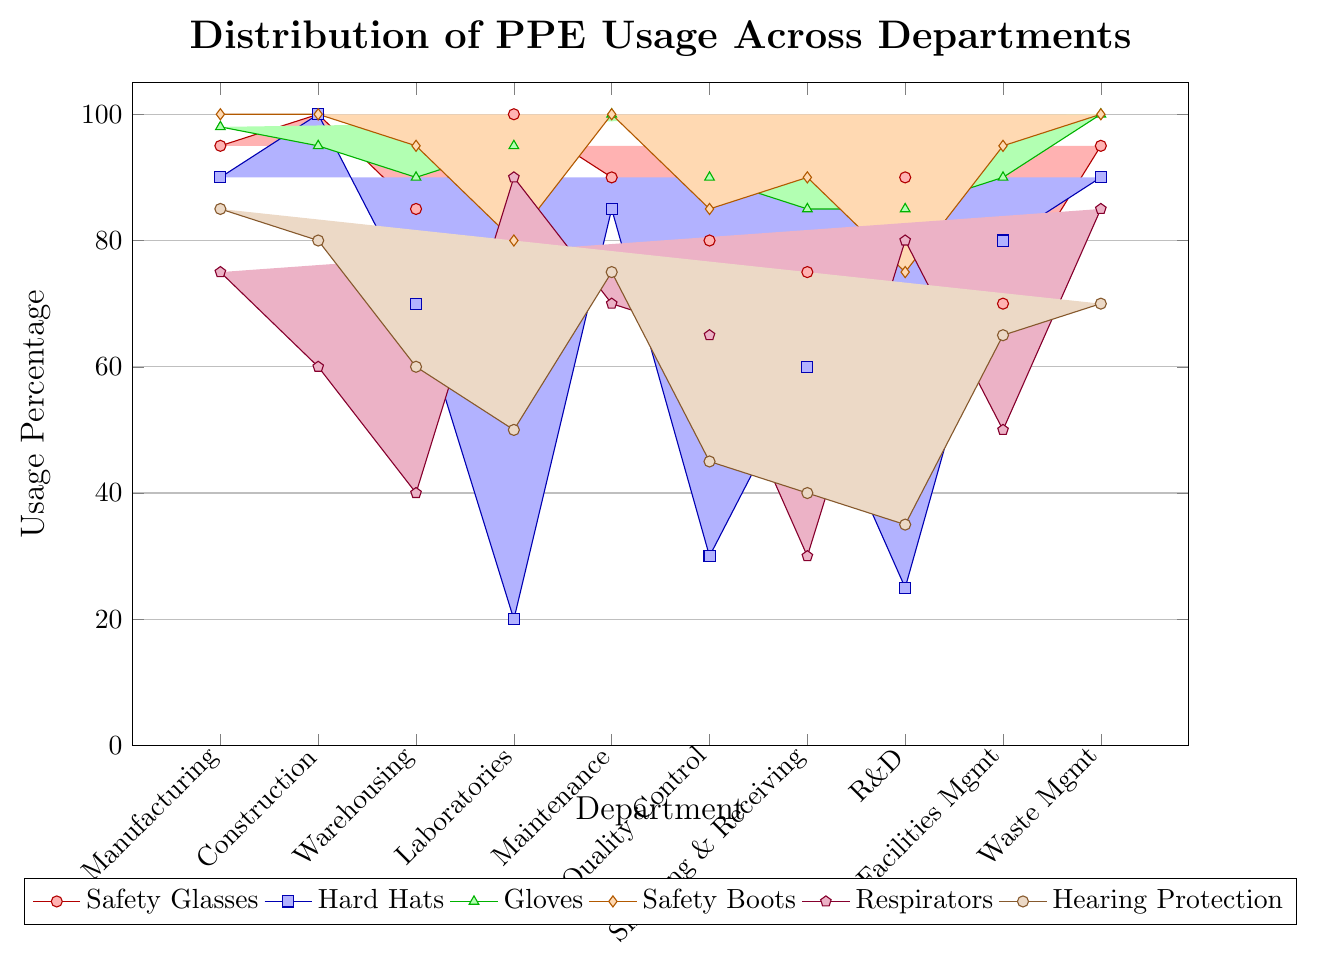Which department has the highest usage of safety glasses? The figure shows the usage of safety glasses in different departments. By comparing the height of the red bars, Laboratories and Construction both show 100% usage, which is the highest.
Answer: Laboratories and Construction Which department uses respirators the least? Examine the purple bars in the figure to determine respirator usage. The Warehousing department shows the shortest purple bar, indicating the lowest usage at 40%.
Answer: Warehousing What is the difference in glove usage between Manufacturing and Warehousing? Identify the green bars for the two departments. Manufacturing has a glove usage of 98%, and Warehousing has 90%. The difference is 98 - 90 = 8%.
Answer: 8% How many departments have 100% safety boots usage? Count the departments where the orange bars reach the maximum height. The Manufacturing, Construction, Maintenance, and Waste Management departments all show 100% usage. Therefore, there are 4 departments.
Answer: 4 Which department has the lowest hard hat usage? Look for the shortest blue bar, which indicates hard hat usage. Laboratories have the shortest blue bar at 20%.
Answer: Laboratories What is the average usage percentage of hearing protection across all departments? Sum the values for hearing protection usage across all departments (85 + 80 + 60 + 50 + 75 + 45 + 40 + 35 + 65 + 70) and divide by the number of departments (10). The sum is 605. So, 605 / 10 = 60.5%.
Answer: 60.5% Do more departments use safety glasses or hard hats above 80%? Count the departments with safety glasses usage above 80% (Manufacturing, Construction, Warehousing, Laboratories, Maintenance, Waste Management – 6 departments). Similarly, count for hard hats (Manufacturing, Construction, Maintenance, Facilities Management, Waste Management – 5 departments). There are more departments with safety glasses usage above 80%.
Answer: Safety glasses For which PPE item is there the largest variation in usage across departments? Evaluate the bar heights for each PPE item across all departments and find the one with the largest variance. Hard hats show a significant range of 20% to 100%, which appears to be the largest variation.
Answer: Hard hats Which department's hearing protection usage is exactly 70%? Look for the brown bar that represents hearing protection with a height corresponding to 70%. The Waste Management department's brown bar matches this criterion.
Answer: Waste Management 